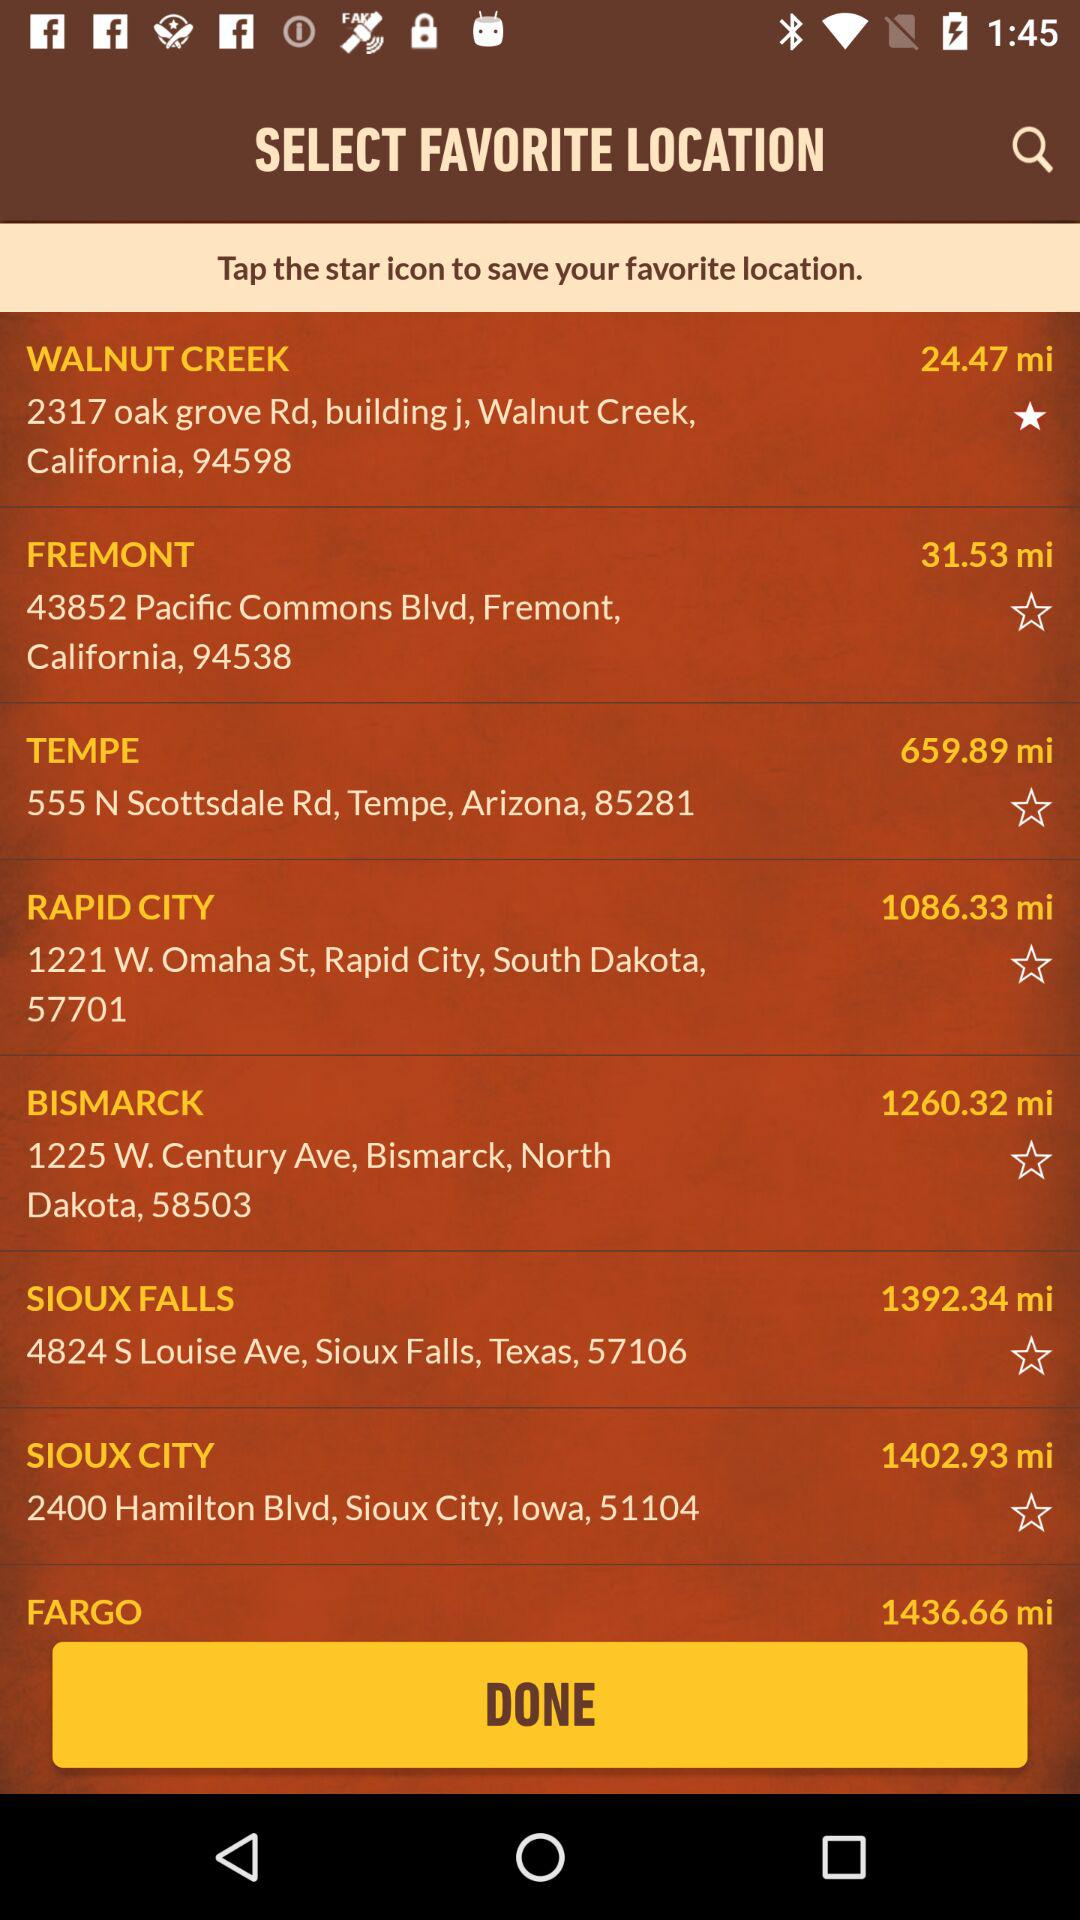What is the location mentioned in "FREMONT"? The mentioned location is 43852 Pacific Commons Blvd, Fremont, California, 94538. 